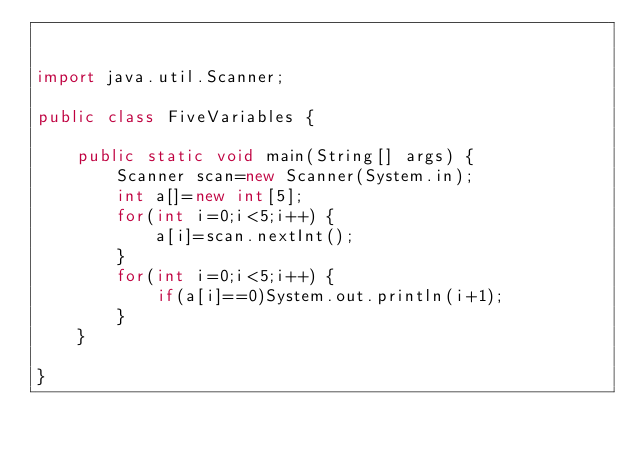Convert code to text. <code><loc_0><loc_0><loc_500><loc_500><_Java_>

import java.util.Scanner;

public class FiveVariables {

	public static void main(String[] args) {
		Scanner scan=new Scanner(System.in);
		int a[]=new int[5];
		for(int i=0;i<5;i++) {
			a[i]=scan.nextInt();
		}
		for(int i=0;i<5;i++) {
			if(a[i]==0)System.out.println(i+1);
		}
	}

}
</code> 